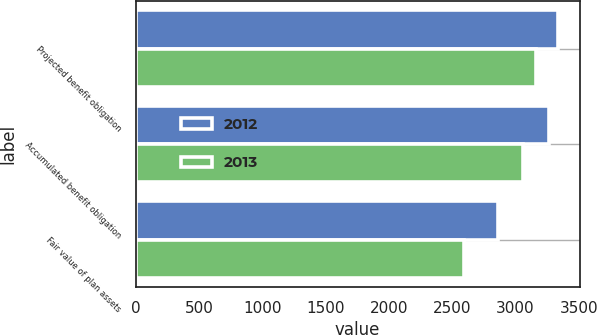Convert chart. <chart><loc_0><loc_0><loc_500><loc_500><stacked_bar_chart><ecel><fcel>Projected benefit obligation<fcel>Accumulated benefit obligation<fcel>Fair value of plan assets<nl><fcel>2012<fcel>3338.8<fcel>3260.7<fcel>2863.3<nl><fcel>2013<fcel>3159.7<fcel>3057.2<fcel>2594.1<nl></chart> 